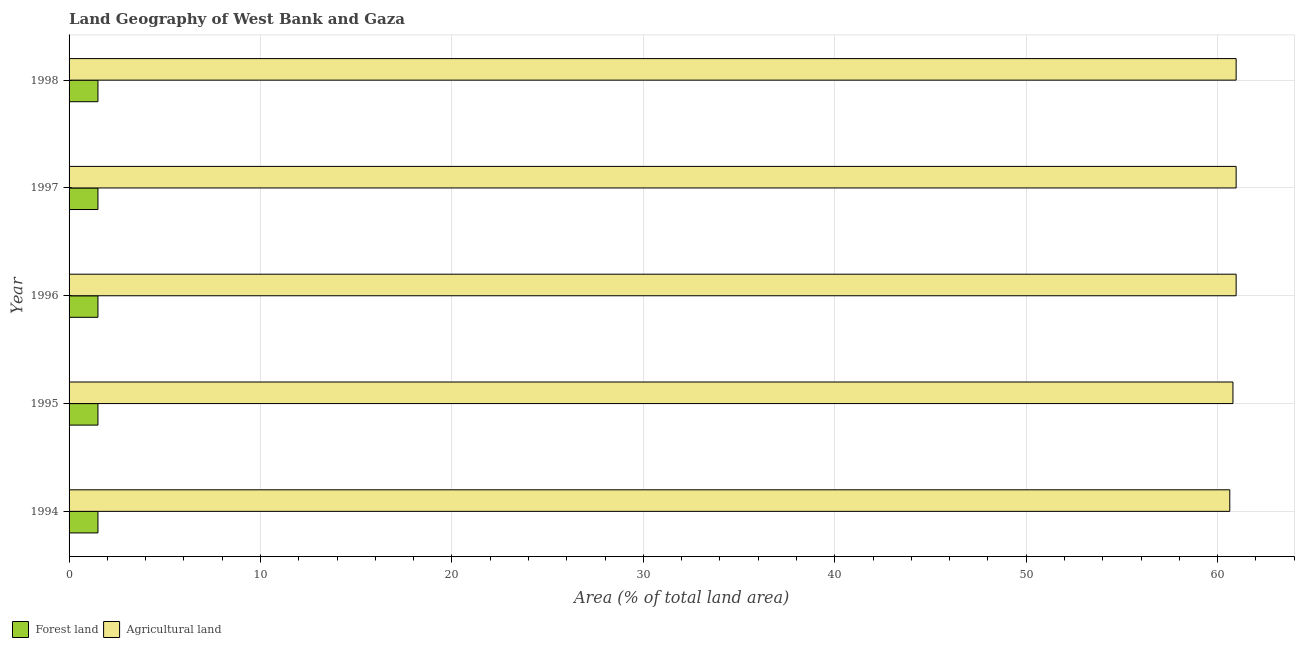Are the number of bars per tick equal to the number of legend labels?
Your response must be concise. Yes. In how many cases, is the number of bars for a given year not equal to the number of legend labels?
Keep it short and to the point. 0. What is the percentage of land area under forests in 1994?
Your answer should be compact. 1.51. Across all years, what is the maximum percentage of land area under forests?
Your answer should be very brief. 1.51. Across all years, what is the minimum percentage of land area under forests?
Offer a terse response. 1.51. What is the total percentage of land area under agriculture in the graph?
Keep it short and to the point. 304.32. What is the difference between the percentage of land area under forests in 1994 and that in 1998?
Your answer should be very brief. 0. What is the difference between the percentage of land area under agriculture in 1998 and the percentage of land area under forests in 1996?
Your answer should be compact. 59.46. What is the average percentage of land area under forests per year?
Make the answer very short. 1.51. In the year 1996, what is the difference between the percentage of land area under agriculture and percentage of land area under forests?
Ensure brevity in your answer.  59.45. In how many years, is the percentage of land area under forests greater than 26 %?
Keep it short and to the point. 0. What is the ratio of the percentage of land area under agriculture in 1994 to that in 1997?
Offer a terse response. 0.99. Is the percentage of land area under agriculture in 1994 less than that in 1996?
Make the answer very short. Yes. Is the difference between the percentage of land area under forests in 1994 and 1995 greater than the difference between the percentage of land area under agriculture in 1994 and 1995?
Make the answer very short. Yes. What is the difference between the highest and the second highest percentage of land area under agriculture?
Give a very brief answer. 0. Is the sum of the percentage of land area under forests in 1996 and 1998 greater than the maximum percentage of land area under agriculture across all years?
Keep it short and to the point. No. What does the 1st bar from the top in 1996 represents?
Your response must be concise. Agricultural land. What does the 2nd bar from the bottom in 1997 represents?
Keep it short and to the point. Agricultural land. How many bars are there?
Give a very brief answer. 10. What is the difference between two consecutive major ticks on the X-axis?
Your answer should be very brief. 10. Are the values on the major ticks of X-axis written in scientific E-notation?
Your answer should be very brief. No. Does the graph contain grids?
Ensure brevity in your answer.  Yes. How are the legend labels stacked?
Your answer should be very brief. Horizontal. What is the title of the graph?
Offer a terse response. Land Geography of West Bank and Gaza. Does "Exports of goods" appear as one of the legend labels in the graph?
Your answer should be compact. No. What is the label or title of the X-axis?
Ensure brevity in your answer.  Area (% of total land area). What is the label or title of the Y-axis?
Offer a terse response. Year. What is the Area (% of total land area) in Forest land in 1994?
Offer a very short reply. 1.51. What is the Area (% of total land area) in Agricultural land in 1994?
Provide a short and direct response. 60.63. What is the Area (% of total land area) of Forest land in 1995?
Keep it short and to the point. 1.51. What is the Area (% of total land area) in Agricultural land in 1995?
Keep it short and to the point. 60.8. What is the Area (% of total land area) of Forest land in 1996?
Give a very brief answer. 1.51. What is the Area (% of total land area) in Agricultural land in 1996?
Provide a short and direct response. 60.96. What is the Area (% of total land area) in Forest land in 1997?
Make the answer very short. 1.51. What is the Area (% of total land area) in Agricultural land in 1997?
Your response must be concise. 60.96. What is the Area (% of total land area) of Forest land in 1998?
Offer a terse response. 1.51. What is the Area (% of total land area) of Agricultural land in 1998?
Offer a very short reply. 60.96. Across all years, what is the maximum Area (% of total land area) in Forest land?
Keep it short and to the point. 1.51. Across all years, what is the maximum Area (% of total land area) in Agricultural land?
Your response must be concise. 60.96. Across all years, what is the minimum Area (% of total land area) of Forest land?
Provide a succinct answer. 1.51. Across all years, what is the minimum Area (% of total land area) in Agricultural land?
Provide a succinct answer. 60.63. What is the total Area (% of total land area) of Forest land in the graph?
Offer a terse response. 7.54. What is the total Area (% of total land area) of Agricultural land in the graph?
Offer a terse response. 304.32. What is the difference between the Area (% of total land area) in Forest land in 1994 and that in 1995?
Your answer should be very brief. 0. What is the difference between the Area (% of total land area) in Agricultural land in 1994 and that in 1995?
Your response must be concise. -0.17. What is the difference between the Area (% of total land area) of Agricultural land in 1994 and that in 1996?
Keep it short and to the point. -0.33. What is the difference between the Area (% of total land area) in Agricultural land in 1994 and that in 1997?
Make the answer very short. -0.33. What is the difference between the Area (% of total land area) of Agricultural land in 1994 and that in 1998?
Offer a terse response. -0.33. What is the difference between the Area (% of total land area) of Agricultural land in 1995 and that in 1996?
Provide a short and direct response. -0.17. What is the difference between the Area (% of total land area) of Agricultural land in 1995 and that in 1997?
Offer a very short reply. -0.17. What is the difference between the Area (% of total land area) of Forest land in 1995 and that in 1998?
Your response must be concise. 0. What is the difference between the Area (% of total land area) of Agricultural land in 1995 and that in 1998?
Provide a succinct answer. -0.17. What is the difference between the Area (% of total land area) in Agricultural land in 1996 and that in 1997?
Provide a short and direct response. 0. What is the difference between the Area (% of total land area) of Forest land in 1996 and that in 1998?
Provide a succinct answer. 0. What is the difference between the Area (% of total land area) in Forest land in 1997 and that in 1998?
Make the answer very short. 0. What is the difference between the Area (% of total land area) in Forest land in 1994 and the Area (% of total land area) in Agricultural land in 1995?
Your answer should be very brief. -59.29. What is the difference between the Area (% of total land area) of Forest land in 1994 and the Area (% of total land area) of Agricultural land in 1996?
Your answer should be very brief. -59.46. What is the difference between the Area (% of total land area) of Forest land in 1994 and the Area (% of total land area) of Agricultural land in 1997?
Give a very brief answer. -59.46. What is the difference between the Area (% of total land area) in Forest land in 1994 and the Area (% of total land area) in Agricultural land in 1998?
Give a very brief answer. -59.46. What is the difference between the Area (% of total land area) of Forest land in 1995 and the Area (% of total land area) of Agricultural land in 1996?
Keep it short and to the point. -59.46. What is the difference between the Area (% of total land area) in Forest land in 1995 and the Area (% of total land area) in Agricultural land in 1997?
Offer a terse response. -59.46. What is the difference between the Area (% of total land area) in Forest land in 1995 and the Area (% of total land area) in Agricultural land in 1998?
Offer a very short reply. -59.46. What is the difference between the Area (% of total land area) of Forest land in 1996 and the Area (% of total land area) of Agricultural land in 1997?
Your answer should be compact. -59.46. What is the difference between the Area (% of total land area) in Forest land in 1996 and the Area (% of total land area) in Agricultural land in 1998?
Keep it short and to the point. -59.46. What is the difference between the Area (% of total land area) of Forest land in 1997 and the Area (% of total land area) of Agricultural land in 1998?
Give a very brief answer. -59.46. What is the average Area (% of total land area) in Forest land per year?
Your response must be concise. 1.51. What is the average Area (% of total land area) in Agricultural land per year?
Provide a short and direct response. 60.86. In the year 1994, what is the difference between the Area (% of total land area) in Forest land and Area (% of total land area) in Agricultural land?
Offer a terse response. -59.12. In the year 1995, what is the difference between the Area (% of total land area) of Forest land and Area (% of total land area) of Agricultural land?
Provide a succinct answer. -59.29. In the year 1996, what is the difference between the Area (% of total land area) in Forest land and Area (% of total land area) in Agricultural land?
Ensure brevity in your answer.  -59.46. In the year 1997, what is the difference between the Area (% of total land area) of Forest land and Area (% of total land area) of Agricultural land?
Your answer should be compact. -59.46. In the year 1998, what is the difference between the Area (% of total land area) in Forest land and Area (% of total land area) in Agricultural land?
Offer a very short reply. -59.46. What is the ratio of the Area (% of total land area) of Agricultural land in 1994 to that in 1995?
Provide a short and direct response. 1. What is the ratio of the Area (% of total land area) of Forest land in 1994 to that in 1996?
Your response must be concise. 1. What is the ratio of the Area (% of total land area) in Agricultural land in 1994 to that in 1997?
Keep it short and to the point. 0.99. What is the ratio of the Area (% of total land area) of Forest land in 1995 to that in 1996?
Offer a terse response. 1. What is the ratio of the Area (% of total land area) of Forest land in 1995 to that in 1997?
Provide a short and direct response. 1. What is the ratio of the Area (% of total land area) of Forest land in 1995 to that in 1998?
Your response must be concise. 1. What is the ratio of the Area (% of total land area) of Agricultural land in 1995 to that in 1998?
Keep it short and to the point. 1. What is the ratio of the Area (% of total land area) in Forest land in 1996 to that in 1997?
Provide a succinct answer. 1. What is the ratio of the Area (% of total land area) in Agricultural land in 1996 to that in 1997?
Your answer should be very brief. 1. What is the ratio of the Area (% of total land area) of Forest land in 1996 to that in 1998?
Provide a short and direct response. 1. What is the ratio of the Area (% of total land area) of Agricultural land in 1996 to that in 1998?
Your answer should be compact. 1. What is the ratio of the Area (% of total land area) of Forest land in 1997 to that in 1998?
Offer a terse response. 1. What is the ratio of the Area (% of total land area) in Agricultural land in 1997 to that in 1998?
Your response must be concise. 1. What is the difference between the highest and the second highest Area (% of total land area) in Forest land?
Provide a succinct answer. 0. What is the difference between the highest and the lowest Area (% of total land area) of Agricultural land?
Your answer should be compact. 0.33. 